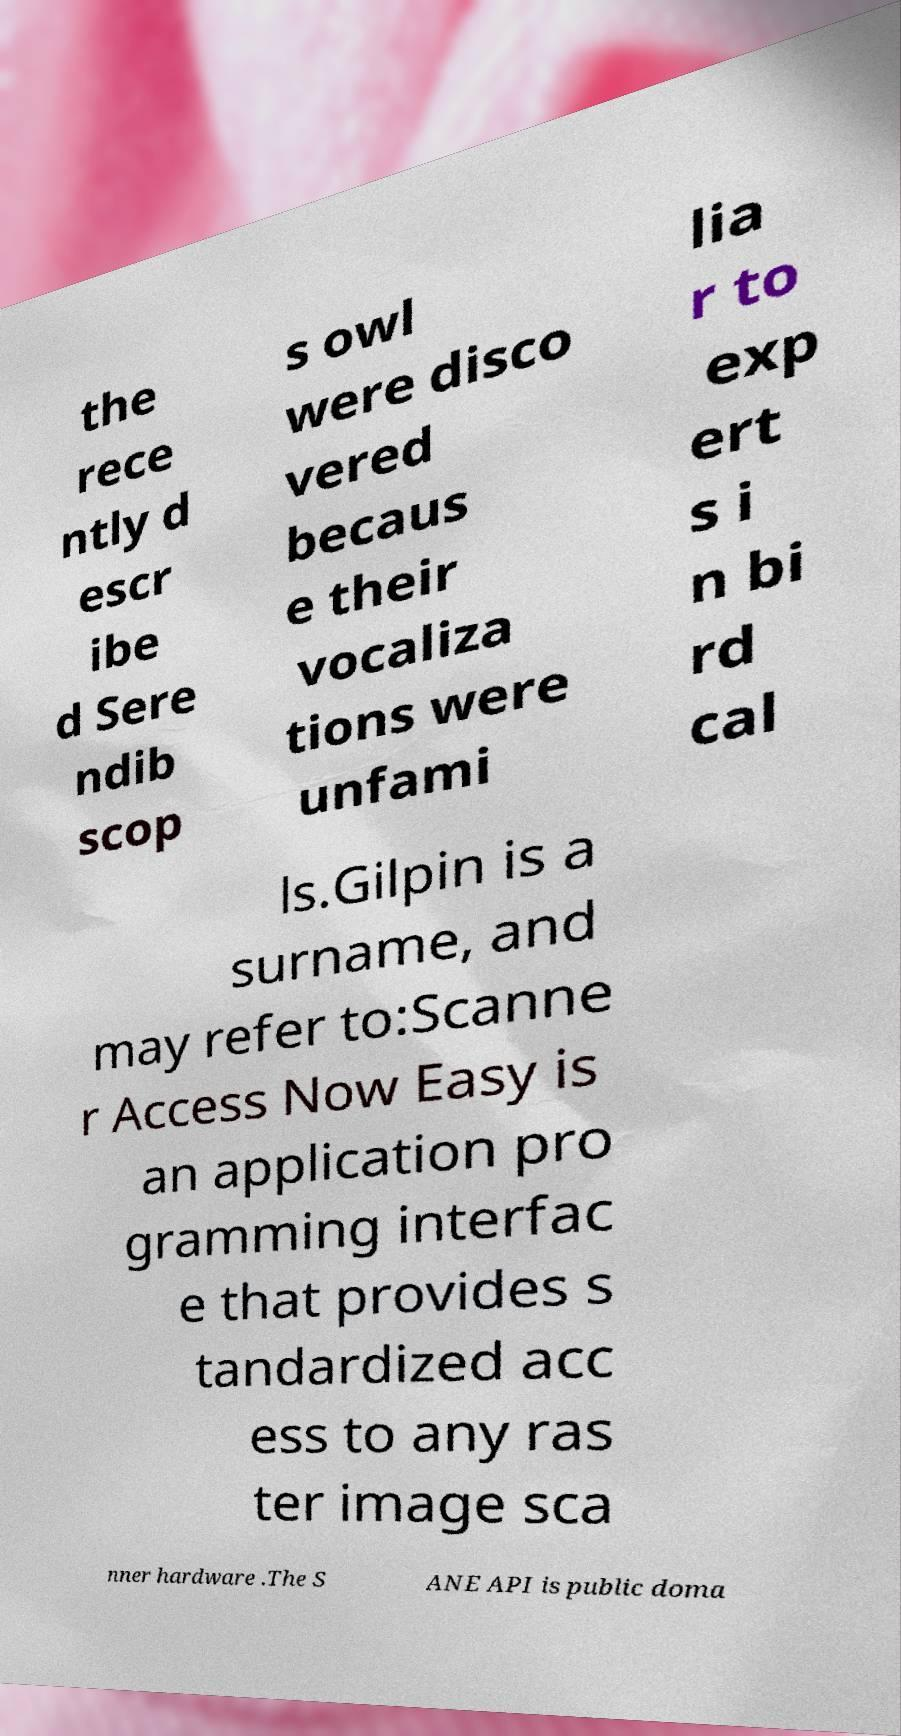Can you read and provide the text displayed in the image?This photo seems to have some interesting text. Can you extract and type it out for me? the rece ntly d escr ibe d Sere ndib scop s owl were disco vered becaus e their vocaliza tions were unfami lia r to exp ert s i n bi rd cal ls.Gilpin is a surname, and may refer to:Scanne r Access Now Easy is an application pro gramming interfac e that provides s tandardized acc ess to any ras ter image sca nner hardware .The S ANE API is public doma 